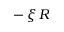Convert formula to latex. <formula><loc_0><loc_0><loc_500><loc_500>- \, \xi \, R</formula> 